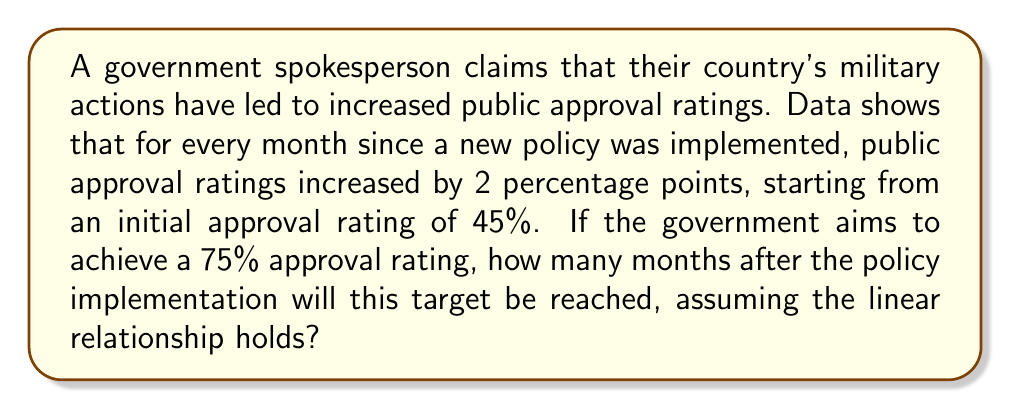Provide a solution to this math problem. Let's approach this step-by-step:

1) First, we need to identify the components of our linear relationship:
   - Initial approval rating (y-intercept): 45%
   - Rate of increase (slope): 2 percentage points per month

2) We can express this as a linear equation:
   $y = 2x + 45$
   where $y$ is the approval rating and $x$ is the number of months.

3) We want to find $x$ when $y = 75$. Let's substitute this into our equation:
   $75 = 2x + 45$

4) Now, let's solve for $x$:
   $75 - 45 = 2x$
   $30 = 2x$

5) Divide both sides by 2:
   $x = 30 \div 2 = 15$

Therefore, it will take 15 months to reach the target approval rating of 75%.
Answer: 15 months 